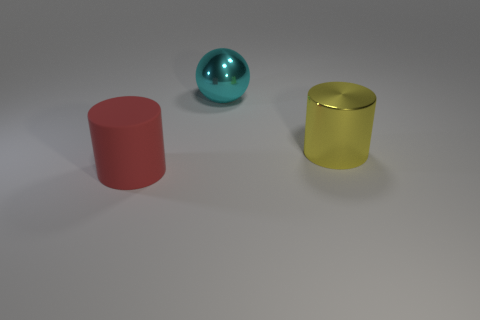What is the color of the thing that is both behind the red object and on the left side of the big yellow cylinder?
Give a very brief answer. Cyan. Is there anything else that has the same material as the red thing?
Your answer should be compact. No. What number of things are either cylinders that are behind the large rubber cylinder or big red balls?
Keep it short and to the point. 1. Are there the same number of large matte cylinders to the right of the red object and red cylinders to the right of the big metal ball?
Keep it short and to the point. Yes. What is the material of the cylinder behind the thing in front of the big shiny object in front of the big cyan sphere?
Ensure brevity in your answer.  Metal. What size is the object that is on the left side of the large yellow metallic cylinder and behind the red object?
Make the answer very short. Large. Do the yellow metallic object and the matte thing have the same shape?
Offer a very short reply. Yes. There is another big thing that is made of the same material as the cyan thing; what shape is it?
Offer a very short reply. Cylinder. What number of small objects are metal cylinders or gray cylinders?
Offer a very short reply. 0. There is a cylinder that is to the right of the big red matte cylinder; are there any big cyan metallic spheres that are in front of it?
Your answer should be very brief. No. 